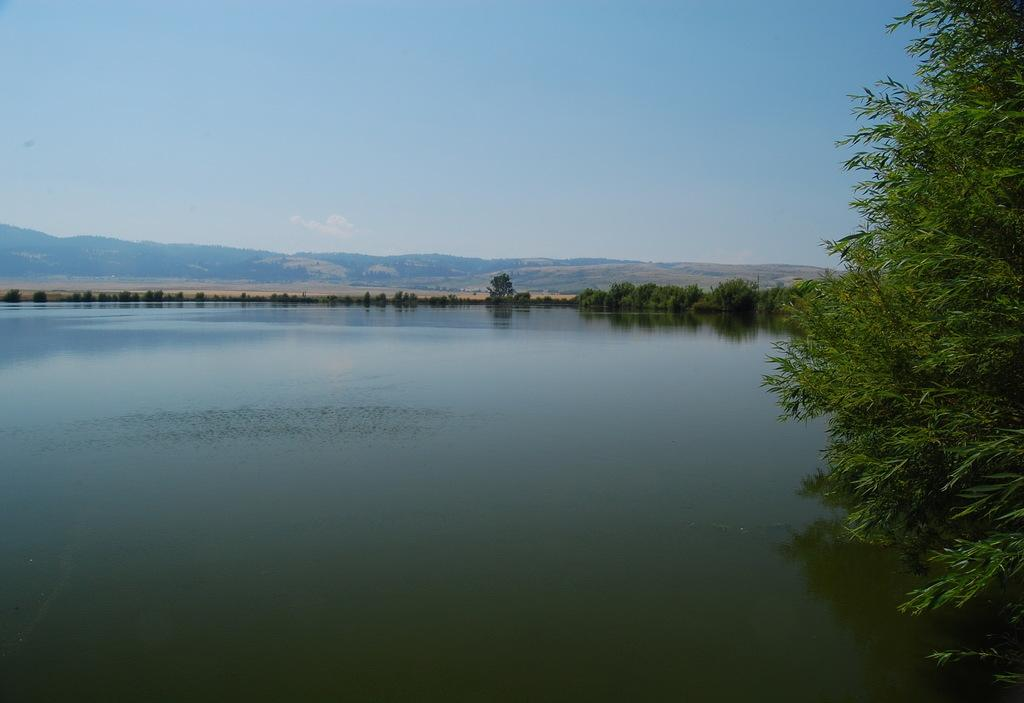What type of natural feature is present in the image? There is a river in the image. What other natural elements can be seen in the image? There are trees in the image. What can be seen in the distance in the image? There are hills visible in the background of the image. What is visible above the hills in the image? The sky is visible in the background of the image. What type of pleasure can be seen enjoying the river in the image? There is no indication of any person or creature enjoying the river in the image, so it cannot be determined from the image. 